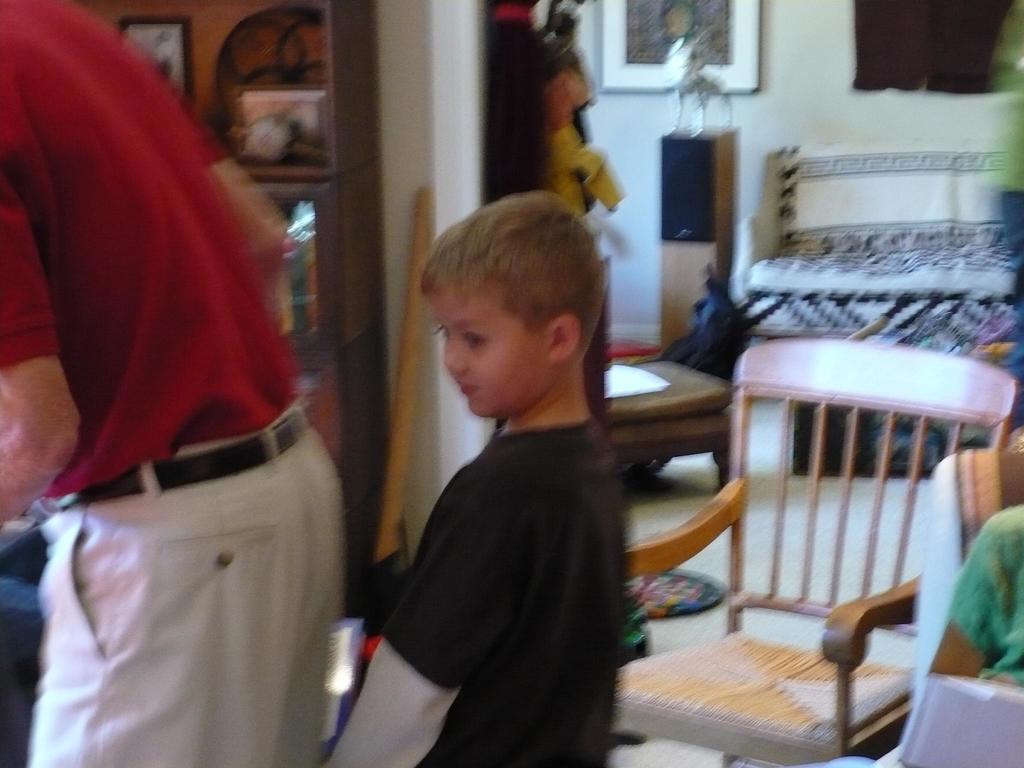Can you describe this image briefly? There is a person standing on the left side. Here we can see a boy standing in the center. In the background we can see a chair and a bed. 